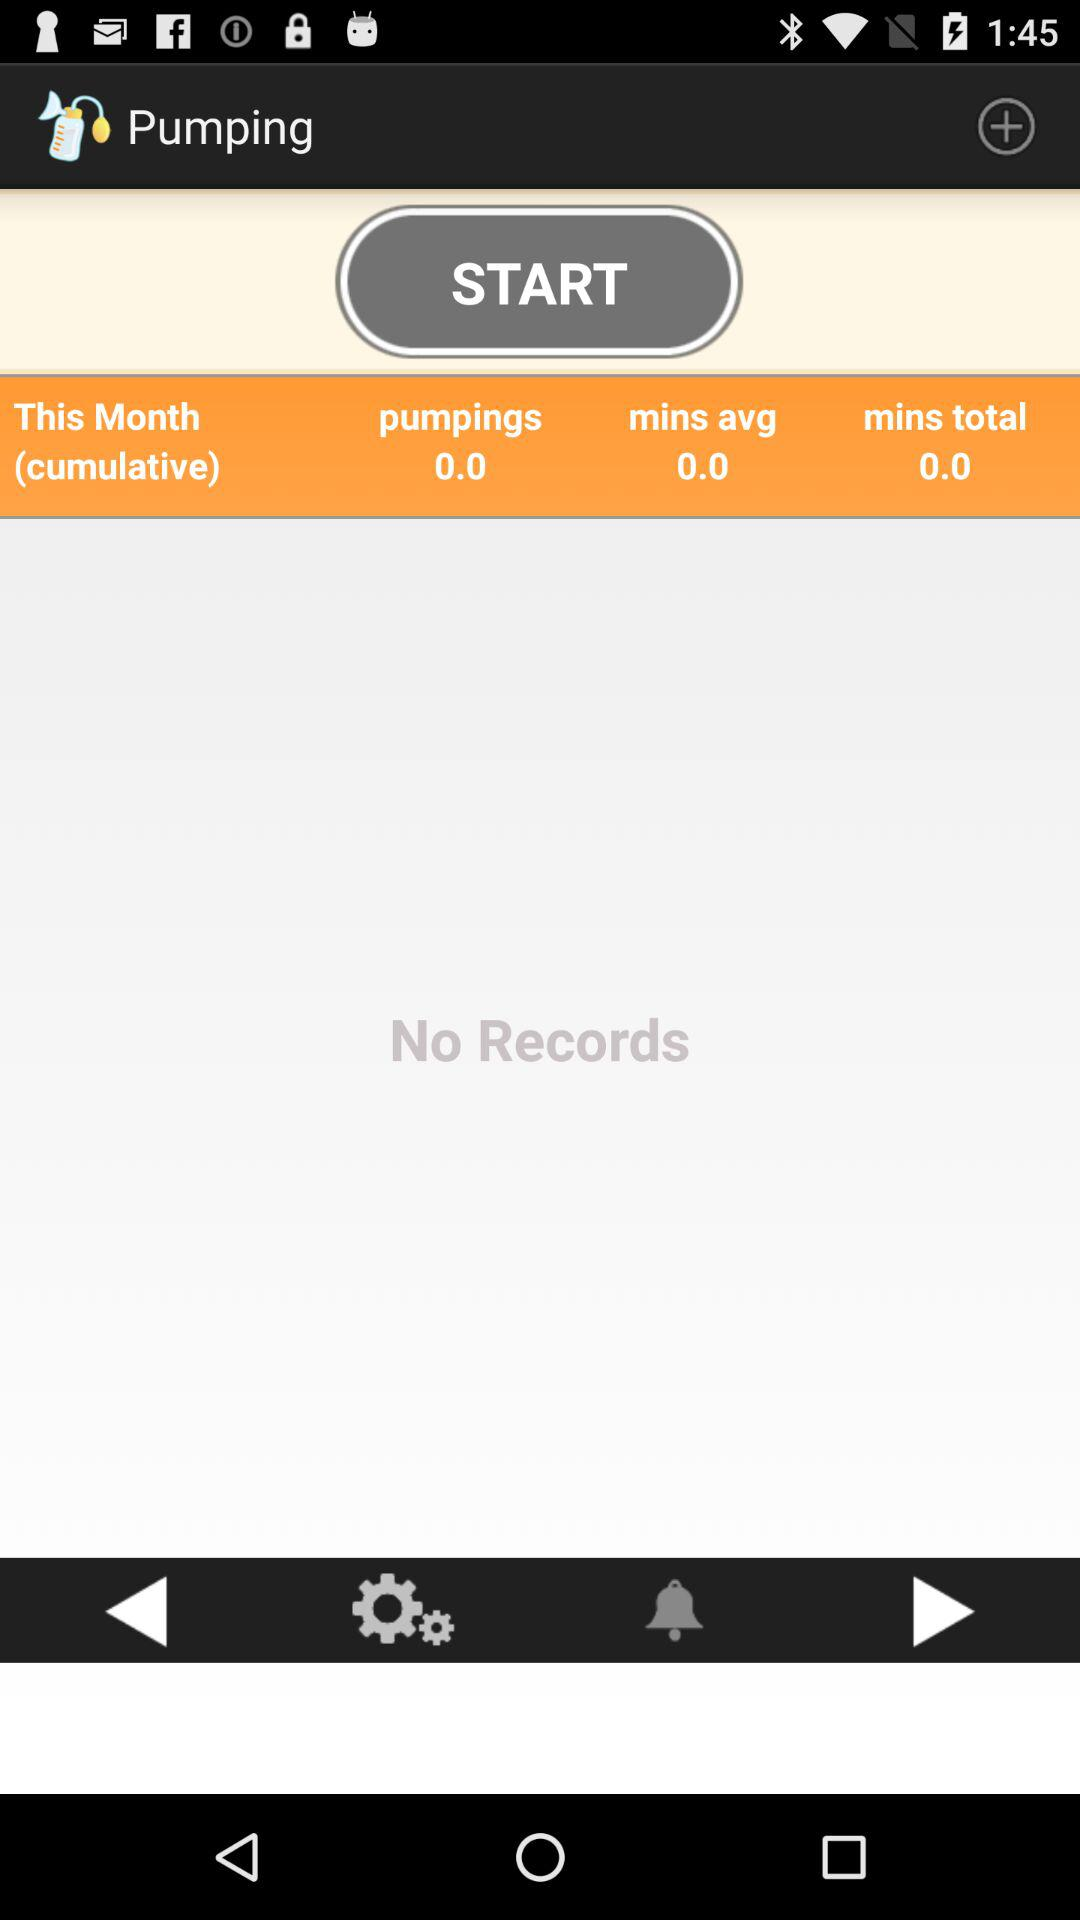How many minutes have I pumped in total?
Answer the question using a single word or phrase. 0.0 